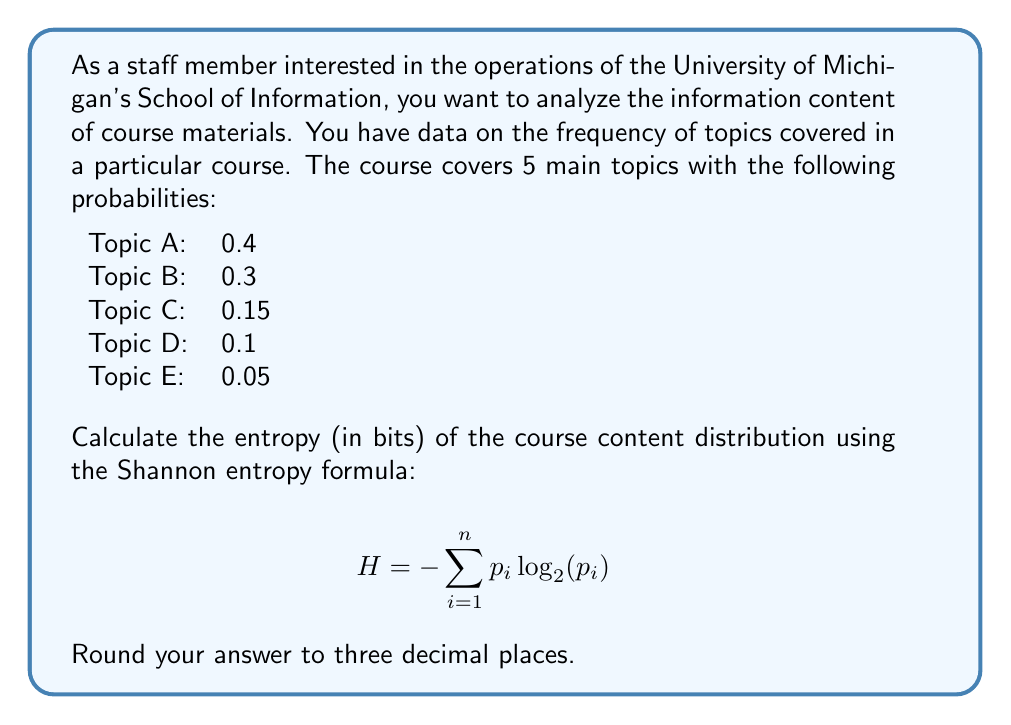Can you solve this math problem? To solve this problem, we'll use the Shannon entropy formula:

$$ H = -\sum_{i=1}^n p_i \log_2(p_i) $$

Where $p_i$ is the probability of each topic, and we're using $\log_2$ to get the result in bits.

Let's calculate each term:

1. For Topic A: $-0.4 \log_2(0.4) = -0.4 \times (-1.3219) = 0.5288$
2. For Topic B: $-0.3 \log_2(0.3) = -0.3 \times (-1.7370) = 0.5211$
3. For Topic C: $-0.15 \log_2(0.15) = -0.15 \times (-2.7370) = 0.4106$
4. For Topic D: $-0.1 \log_2(0.1) = -0.1 \times (-3.3219) = 0.3322$
5. For Topic E: $-0.05 \log_2(0.05) = -0.05 \times (-4.3219) = 0.2161$

Now, we sum all these terms:

$$ H = 0.5288 + 0.5211 + 0.4106 + 0.3322 + 0.2161 = 2.0088 $$

Rounding to three decimal places, we get 2.009 bits.
Answer: 2.009 bits 